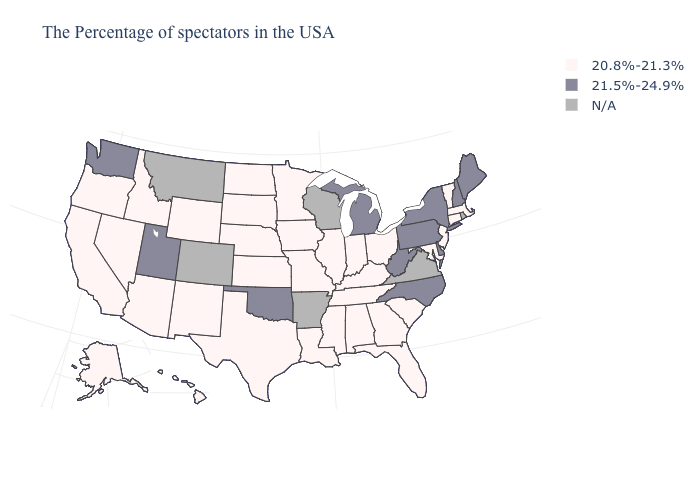Does Utah have the lowest value in the USA?
Quick response, please. No. What is the value of Iowa?
Keep it brief. 20.8%-21.3%. Does Michigan have the highest value in the MidWest?
Write a very short answer. Yes. Does the first symbol in the legend represent the smallest category?
Keep it brief. Yes. What is the highest value in states that border New York?
Give a very brief answer. 21.5%-24.9%. Does the map have missing data?
Answer briefly. Yes. What is the value of South Dakota?
Short answer required. 20.8%-21.3%. Which states have the highest value in the USA?
Concise answer only. Maine, New Hampshire, New York, Delaware, Pennsylvania, North Carolina, West Virginia, Michigan, Oklahoma, Utah, Washington. What is the value of Kentucky?
Quick response, please. 20.8%-21.3%. Name the states that have a value in the range 20.8%-21.3%?
Give a very brief answer. Massachusetts, Vermont, Connecticut, New Jersey, Maryland, South Carolina, Ohio, Florida, Georgia, Kentucky, Indiana, Alabama, Tennessee, Illinois, Mississippi, Louisiana, Missouri, Minnesota, Iowa, Kansas, Nebraska, Texas, South Dakota, North Dakota, Wyoming, New Mexico, Arizona, Idaho, Nevada, California, Oregon, Alaska, Hawaii. Which states have the highest value in the USA?
Quick response, please. Maine, New Hampshire, New York, Delaware, Pennsylvania, North Carolina, West Virginia, Michigan, Oklahoma, Utah, Washington. Does the map have missing data?
Concise answer only. Yes. What is the value of Maine?
Short answer required. 21.5%-24.9%. 